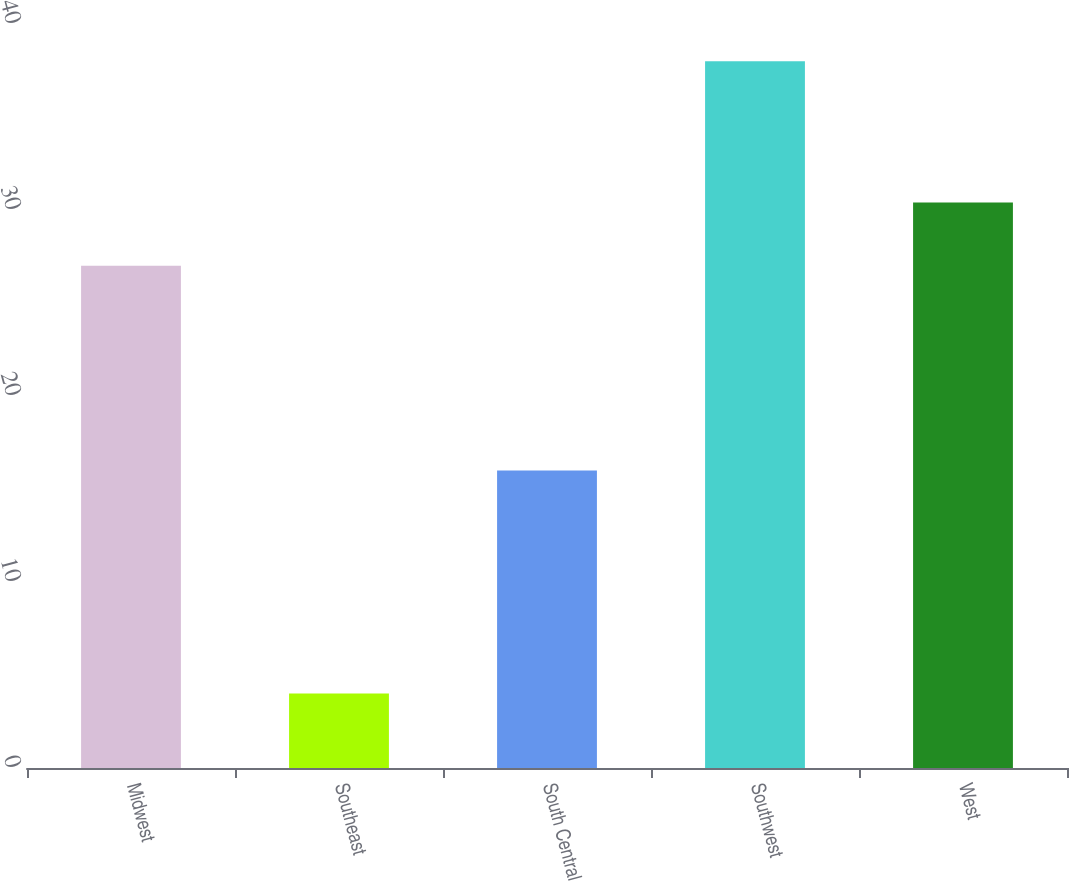<chart> <loc_0><loc_0><loc_500><loc_500><bar_chart><fcel>Midwest<fcel>Southeast<fcel>South Central<fcel>Southwest<fcel>West<nl><fcel>27<fcel>4<fcel>16<fcel>38<fcel>30.4<nl></chart> 